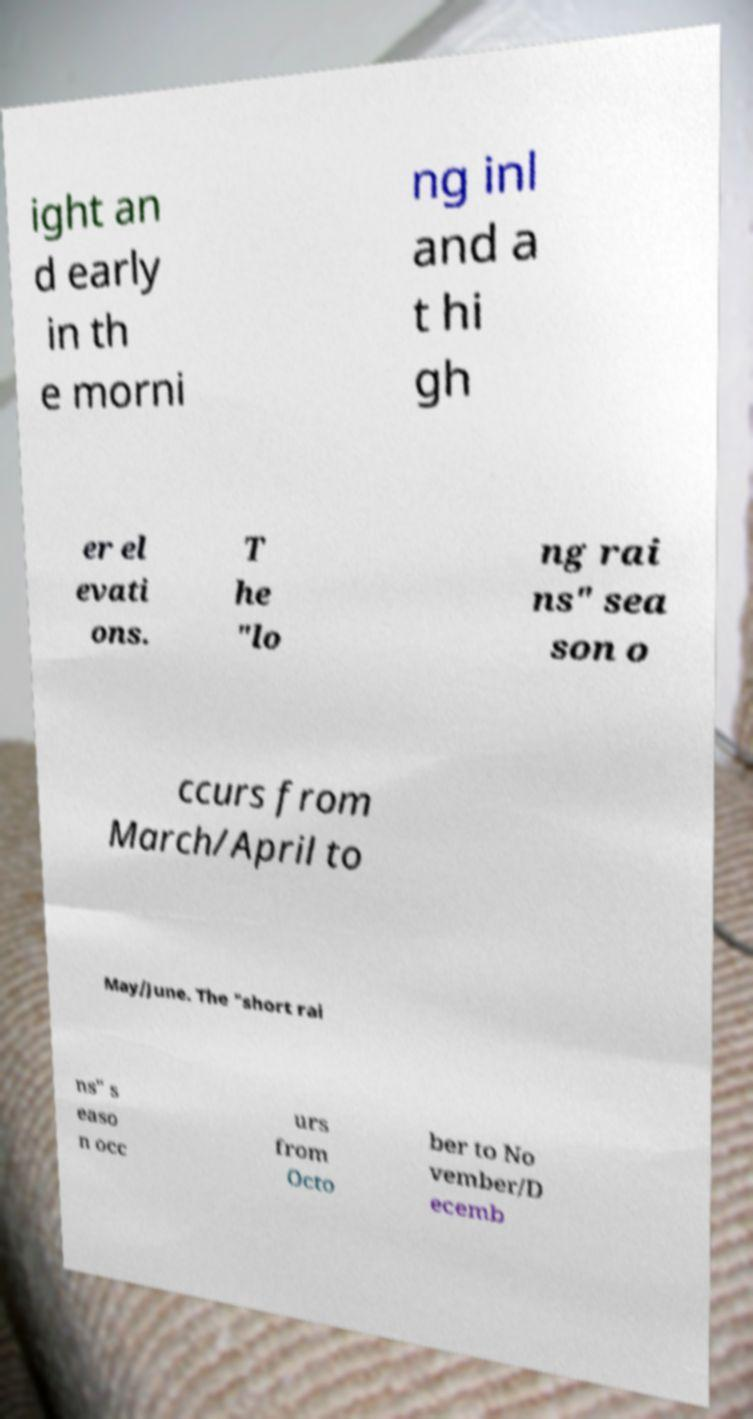Can you read and provide the text displayed in the image?This photo seems to have some interesting text. Can you extract and type it out for me? ight an d early in th e morni ng inl and a t hi gh er el evati ons. T he "lo ng rai ns" sea son o ccurs from March/April to May/June. The "short rai ns" s easo n occ urs from Octo ber to No vember/D ecemb 